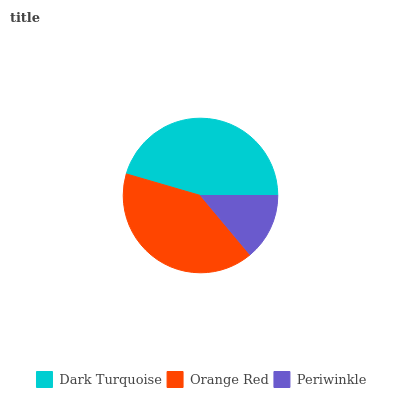Is Periwinkle the minimum?
Answer yes or no. Yes. Is Dark Turquoise the maximum?
Answer yes or no. Yes. Is Orange Red the minimum?
Answer yes or no. No. Is Orange Red the maximum?
Answer yes or no. No. Is Dark Turquoise greater than Orange Red?
Answer yes or no. Yes. Is Orange Red less than Dark Turquoise?
Answer yes or no. Yes. Is Orange Red greater than Dark Turquoise?
Answer yes or no. No. Is Dark Turquoise less than Orange Red?
Answer yes or no. No. Is Orange Red the high median?
Answer yes or no. Yes. Is Orange Red the low median?
Answer yes or no. Yes. Is Dark Turquoise the high median?
Answer yes or no. No. Is Dark Turquoise the low median?
Answer yes or no. No. 